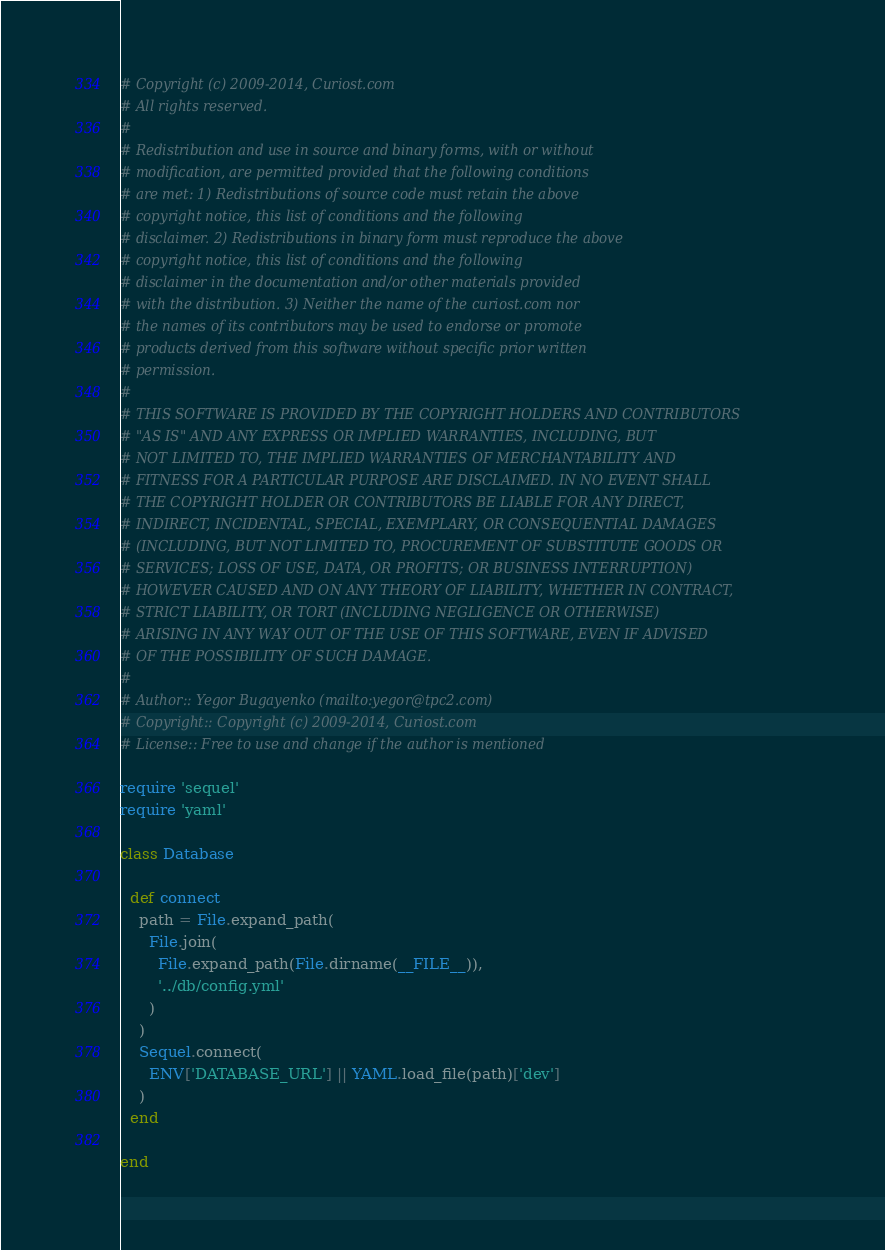Convert code to text. <code><loc_0><loc_0><loc_500><loc_500><_Ruby_># Copyright (c) 2009-2014, Curiost.com
# All rights reserved.
#
# Redistribution and use in source and binary forms, with or without
# modification, are permitted provided that the following conditions
# are met: 1) Redistributions of source code must retain the above
# copyright notice, this list of conditions and the following
# disclaimer. 2) Redistributions in binary form must reproduce the above
# copyright notice, this list of conditions and the following
# disclaimer in the documentation and/or other materials provided
# with the distribution. 3) Neither the name of the curiost.com nor
# the names of its contributors may be used to endorse or promote
# products derived from this software without specific prior written
# permission.
#
# THIS SOFTWARE IS PROVIDED BY THE COPYRIGHT HOLDERS AND CONTRIBUTORS
# "AS IS" AND ANY EXPRESS OR IMPLIED WARRANTIES, INCLUDING, BUT
# NOT LIMITED TO, THE IMPLIED WARRANTIES OF MERCHANTABILITY AND
# FITNESS FOR A PARTICULAR PURPOSE ARE DISCLAIMED. IN NO EVENT SHALL
# THE COPYRIGHT HOLDER OR CONTRIBUTORS BE LIABLE FOR ANY DIRECT,
# INDIRECT, INCIDENTAL, SPECIAL, EXEMPLARY, OR CONSEQUENTIAL DAMAGES
# (INCLUDING, BUT NOT LIMITED TO, PROCUREMENT OF SUBSTITUTE GOODS OR
# SERVICES; LOSS OF USE, DATA, OR PROFITS; OR BUSINESS INTERRUPTION)
# HOWEVER CAUSED AND ON ANY THEORY OF LIABILITY, WHETHER IN CONTRACT,
# STRICT LIABILITY, OR TORT (INCLUDING NEGLIGENCE OR OTHERWISE)
# ARISING IN ANY WAY OUT OF THE USE OF THIS SOFTWARE, EVEN IF ADVISED
# OF THE POSSIBILITY OF SUCH DAMAGE.
#
# Author:: Yegor Bugayenko (mailto:yegor@tpc2.com)
# Copyright:: Copyright (c) 2009-2014, Curiost.com
# License:: Free to use and change if the author is mentioned

require 'sequel'
require 'yaml'

class Database

  def connect
    path = File.expand_path(
      File.join(
        File.expand_path(File.dirname(__FILE__)),
        '../db/config.yml'
      )
    )
    Sequel.connect(
      ENV['DATABASE_URL'] || YAML.load_file(path)['dev']
    )
  end

end
</code> 